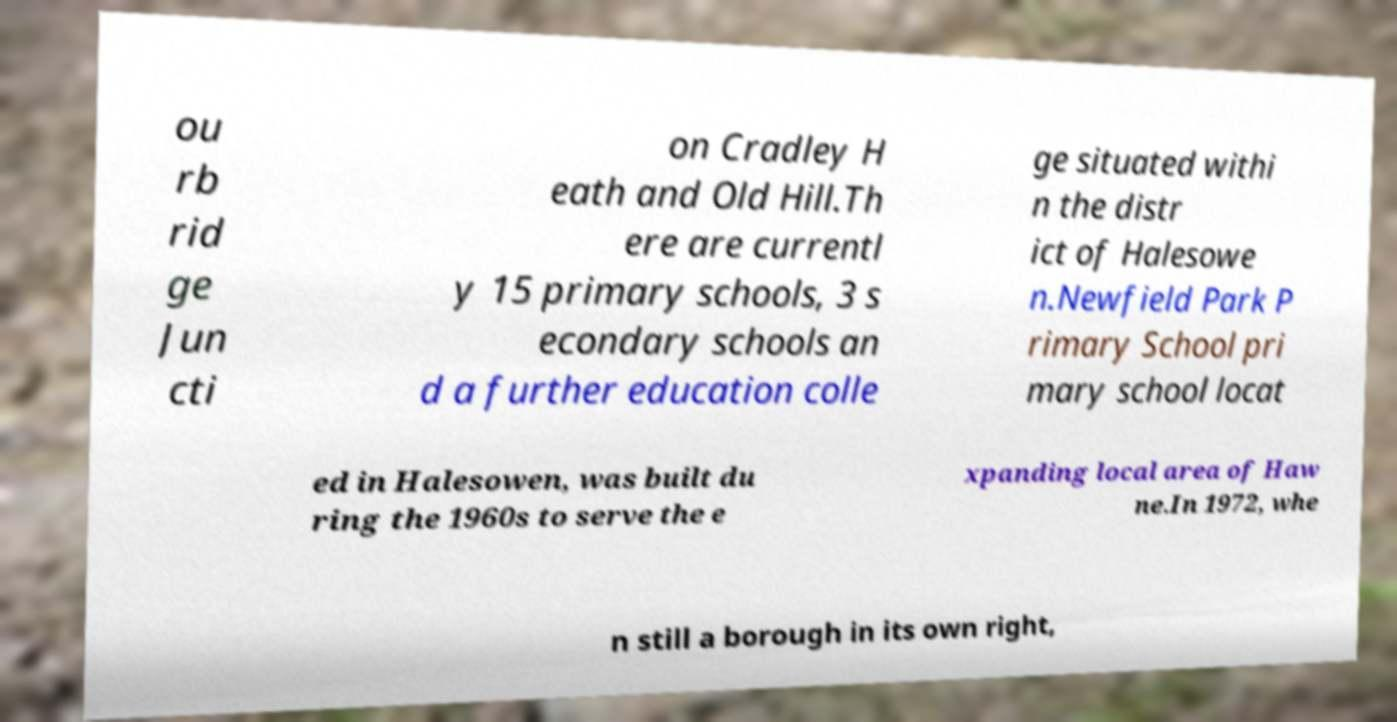I need the written content from this picture converted into text. Can you do that? ou rb rid ge Jun cti on Cradley H eath and Old Hill.Th ere are currentl y 15 primary schools, 3 s econdary schools an d a further education colle ge situated withi n the distr ict of Halesowe n.Newfield Park P rimary School pri mary school locat ed in Halesowen, was built du ring the 1960s to serve the e xpanding local area of Haw ne.In 1972, whe n still a borough in its own right, 